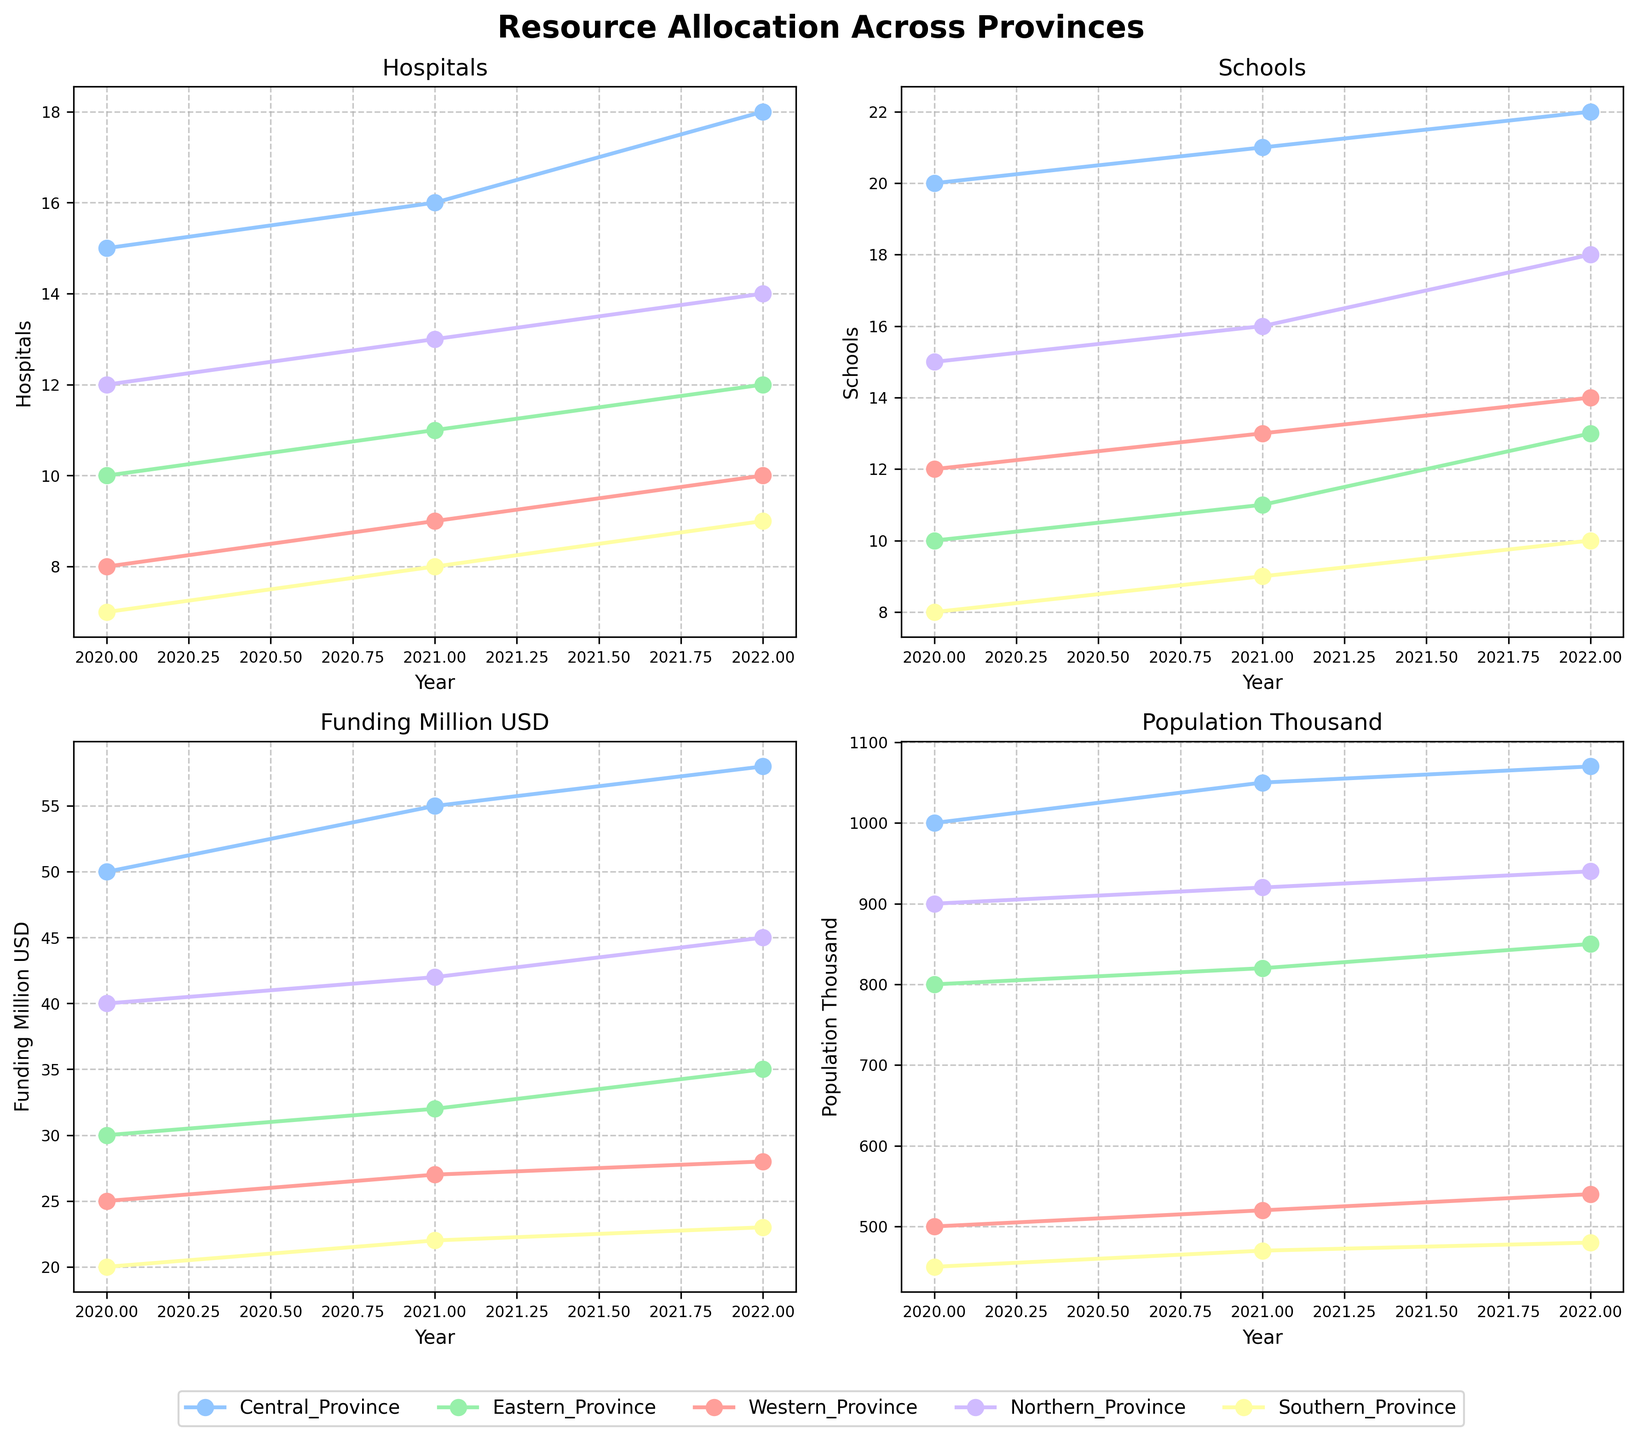What is the title of the plot? The title is displayed at the top of the figure in a large, bold font and reads "Resource Allocation Across Provinces".
Answer: Resource Allocation Across Provinces How many years are displayed in each subplot? By counting the x-axis labels for any subplot, you can see there are three years: 2020, 2021, and 2022.
Answer: 3 Which province had the highest number of hospitals in 2022? By looking at the 'Hospitals' subplot and following the lines for 2022, the Central Province has the highest number of hospitals with 18.
Answer: Central Province How did the number of schools change in the Northern Province from 2020 to 2022? In the 'Schools' subplot, following the line for Northern Province shows the number of schools increased from 15 in 2020 to 18 in 2022.
Answer: Increased by 3 Which province received the least funding in 2020? In the 'Funding_Million_USD' subplot, checking the values for 2020 shows that the Southern Province received the least funding with 20 million USD.
Answer: Southern Province Does the Central Province always have the highest population each year? Looking at the 'Population_Thousand' subplot, the Central Province has the highest population in 2020, 2021, and 2022, consistently higher than other provinces.
Answer: Yes By how much did the funding for the Eastern Province increase from 2020 to 2021? In the 'Funding_Million_USD' subplot, for the Eastern Province, the funding increased from 30 million USD in 2020 to 32 million USD in 2021, an increase of 2 million USD.
Answer: 2 million USD Which province shows the most stability in the number of hospitals over the years? By observing the 'Hospitals' subplot, the Southern Province shows the smallest changes, increasing consistently but slowly, suggesting stability.
Answer: Southern Province Between 2020 and 2022, which province experienced the sharpest increase in the number of schools? In the 'Schools' subplot, the Eastern Province shows an increase from 10 in 2020 to 13 in 2022, the highest proportional increase among all provinces.
Answer: Eastern Province How does the funding trend for the Western Province compare to the Central Province? From the 'Funding_Million_USD' subplot, the Western Province shows a steady but slower increase, while the Central Province shows a pronounced and higher increase over the years.
Answer: The Central Province increases more sharply 